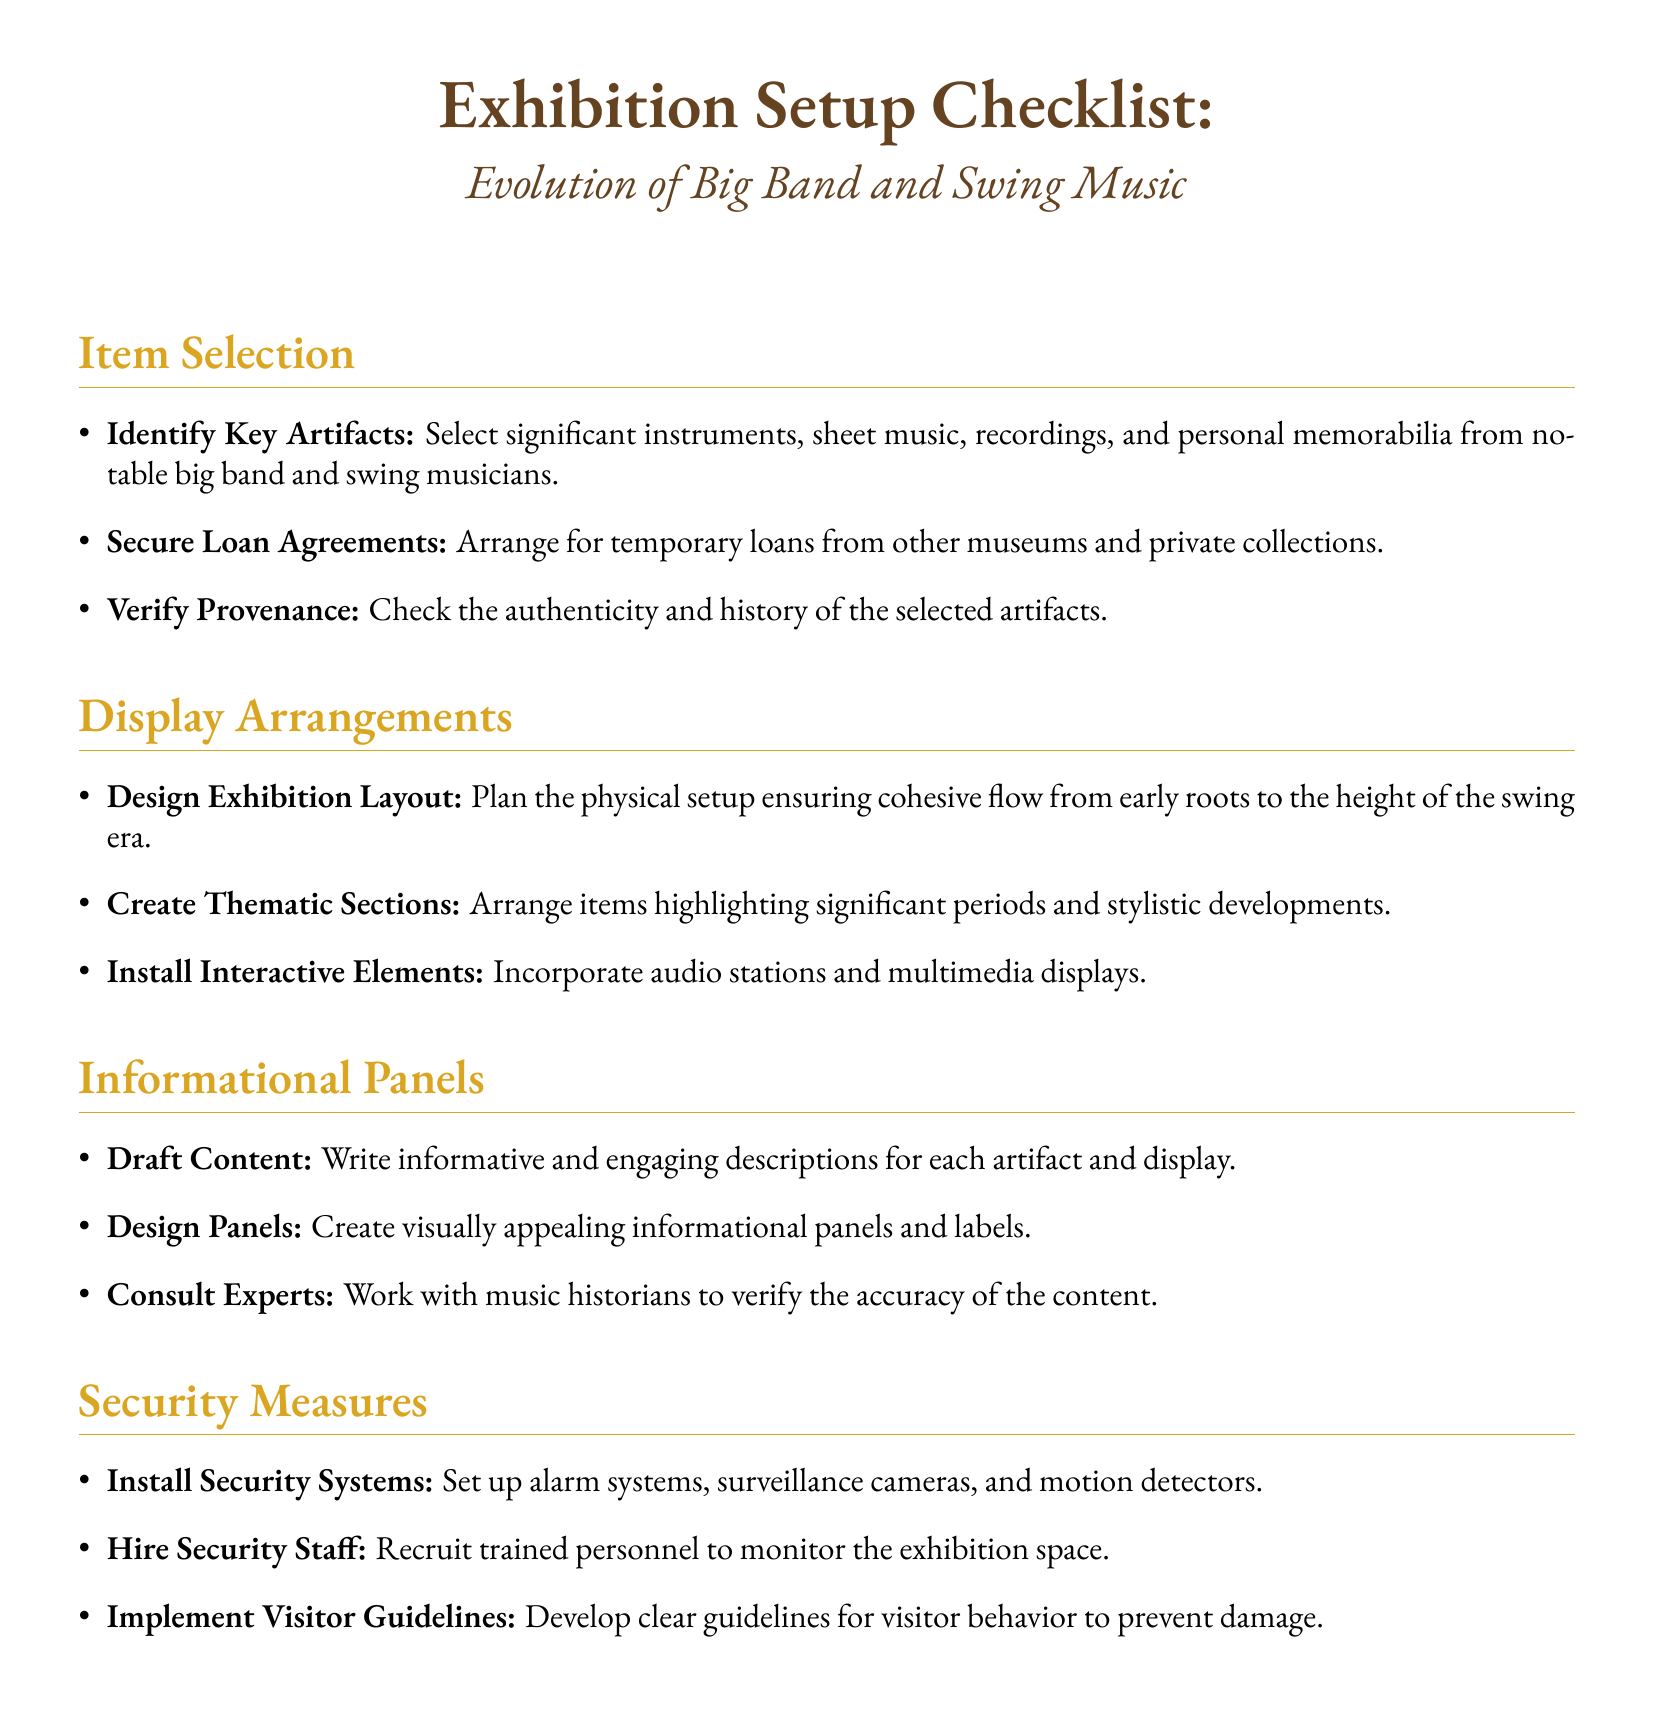what is the first task listed under Item Selection? The first task under Item Selection is to identify significant artifacts.
Answer: Identify Key Artifacts how many sections are there in the Display Arrangements? There are three tasks listed under Display Arrangements.
Answer: Three what aspect does the 'Install Interactive Elements' focus on? This task focuses on incorporating engaging components such as audio stations and multimedia displays.
Answer: Interactive Elements which security measure involves human oversight? Hiring trained personnel to monitor the exhibition space involves human oversight.
Answer: Hire Security Staff who should be consulted for verifying content accuracy in the Informational Panels? The document suggests consulting music historians for this purpose.
Answer: Music historians in what way does the 'Verify Provenance' task contribute to the exhibit? It ensures the authenticity and history of the selected artifacts, contributing to the exhibit's credibility.
Answer: Authenticity and history what type of content is emphasized for the Draft Content task? The emphasis is on writing informative and engaging descriptions for each artifact and display.
Answer: Informative and engaging descriptions how is the exhibition layout meant to be structured? The exhibition layout is planned to ensure a cohesive flow from early roots to the height of the swing era.
Answer: Cohesive flow what does the document specify as an essential element to include with artifacts? The document specifies that significant instruments, sheet music, recordings, and personal memorabilia are essential elements.
Answer: Significant instruments, sheet music, recordings, and personal memorabilia 